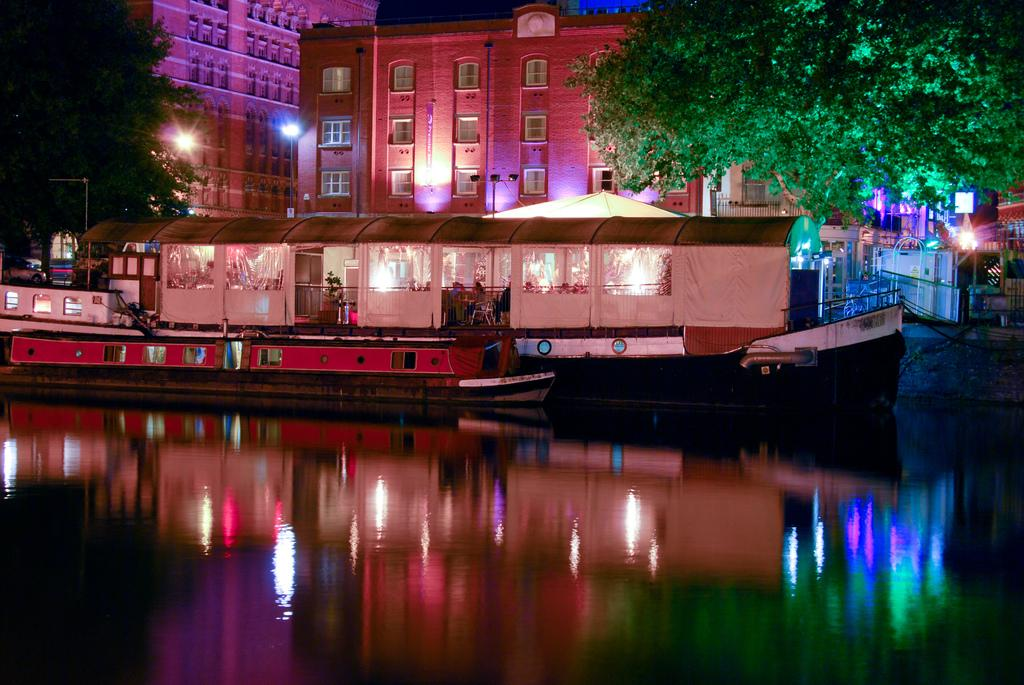What type of vehicles can be seen on the water in the image? There are ships on the water in the image. Are there any people on the ships? Yes, people are present inside the ships. What can be seen in the background of the image? There are trees and buildings in the background. What additional feature is visible in the image? Colorful lights are visible. What type of produce is being harvested in the image? There is no produce or harvesting activity present in the image; it features ships on the water with people on board. 